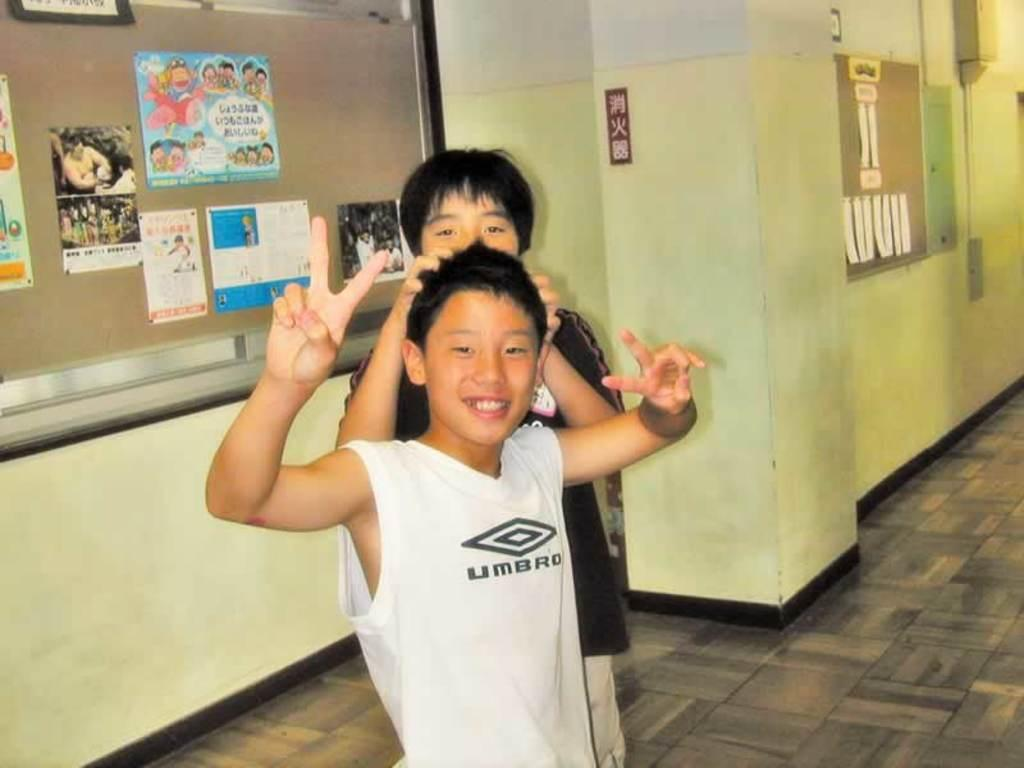What is the main subject of the image? The main subject of the image is the boys standing in the center. Can you describe the position of the boys in the image? The boys are standing in the center of the image. What can be seen in the background of the image? There are boards placed on the wall in the background of the image. What type of corn is being harvested in the image? There is no corn present in the image; it features boys standing in the center and boards on the wall in the background. 